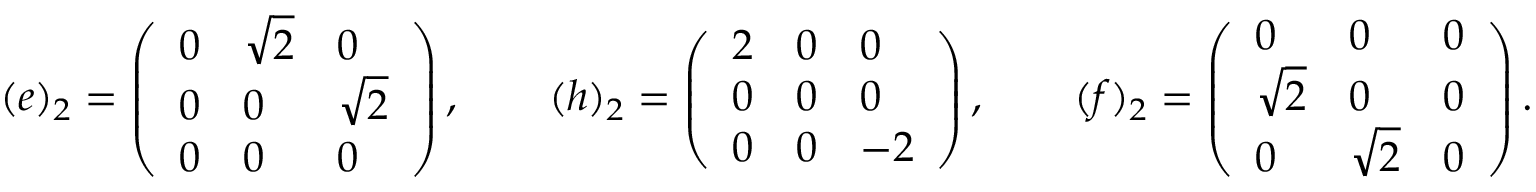<formula> <loc_0><loc_0><loc_500><loc_500>( e ) _ { 2 } = \left ( \begin{array} { l l l } { 0 } & { \sqrt { 2 } } & { 0 } \\ { 0 } & { 0 } & { \sqrt { 2 } } \\ { 0 } & { 0 } & { 0 } \end{array} \right ) , \quad ( h ) _ { 2 } = \left ( \begin{array} { l l l } { 2 } & { 0 } & { 0 } \\ { 0 } & { 0 } & { 0 } \\ { 0 } & { 0 } & { - 2 } \end{array} \right ) , \quad ( f ) _ { 2 } = \left ( \begin{array} { l l l } { 0 } & { 0 } & { 0 } \\ { \sqrt { 2 } } & { 0 } & { 0 } \\ { 0 } & { \sqrt { 2 } } & { 0 } \end{array} \right ) .</formula> 